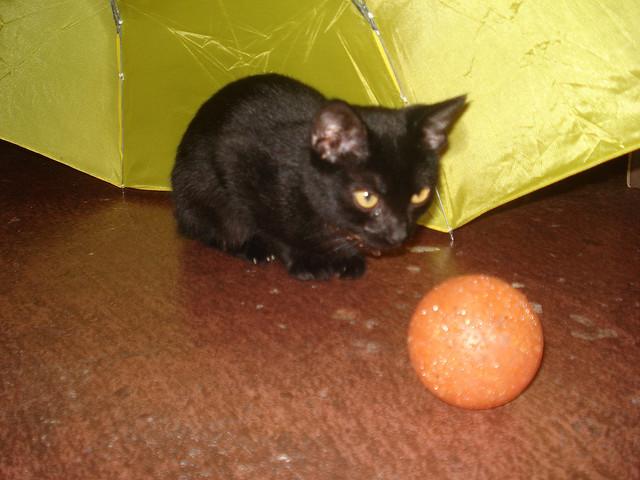What is the surface of the floor made of?
Keep it brief. Wood. Is that a yellow umbrella behind the cat?
Answer briefly. Yes. Is this cat fully grown?
Quick response, please. No. 